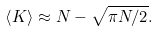Convert formula to latex. <formula><loc_0><loc_0><loc_500><loc_500>\left \langle K \right \rangle \approx N - \sqrt { \pi N / 2 } .</formula> 